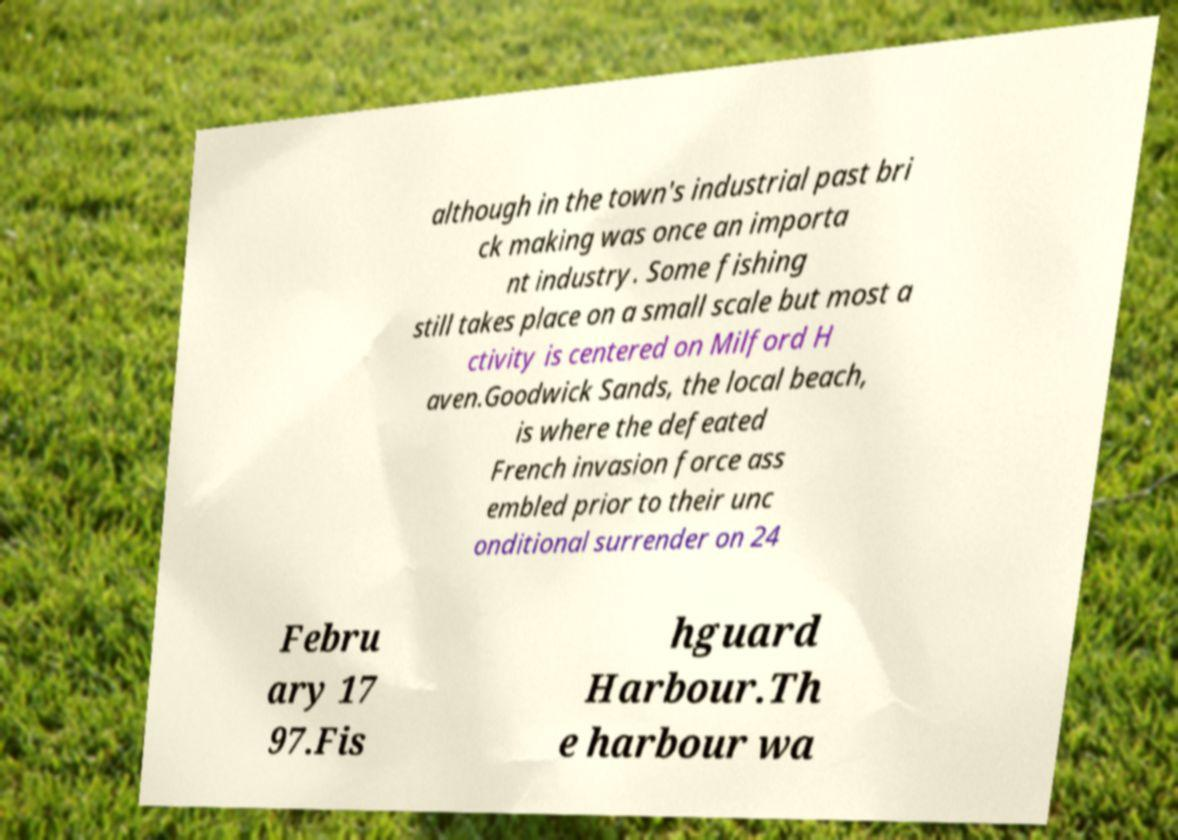What messages or text are displayed in this image? I need them in a readable, typed format. although in the town's industrial past bri ck making was once an importa nt industry. Some fishing still takes place on a small scale but most a ctivity is centered on Milford H aven.Goodwick Sands, the local beach, is where the defeated French invasion force ass embled prior to their unc onditional surrender on 24 Febru ary 17 97.Fis hguard Harbour.Th e harbour wa 